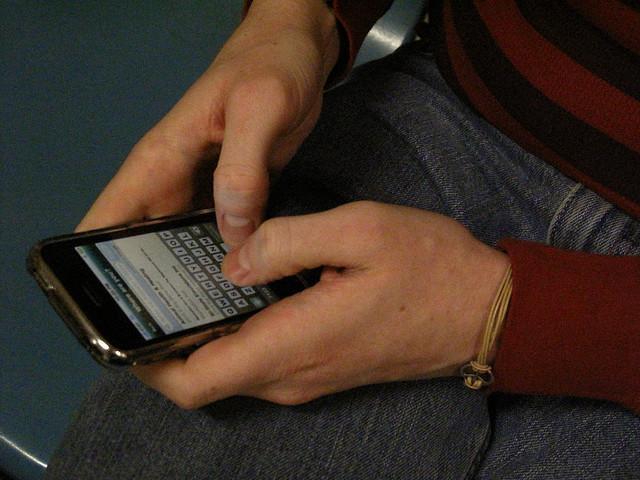How many horses are in the picture?
Give a very brief answer. 0. 